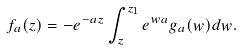Convert formula to latex. <formula><loc_0><loc_0><loc_500><loc_500>f _ { a } ( z ) = - e ^ { - a z } \int _ { z } ^ { z _ { 1 } } e ^ { w a } g _ { a } ( w ) d w .</formula> 